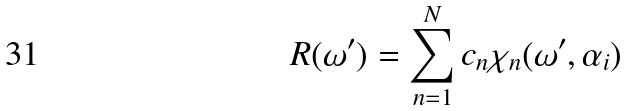<formula> <loc_0><loc_0><loc_500><loc_500>R ( \omega ^ { \prime } ) = \sum _ { n = 1 } ^ { N } c _ { n } \chi _ { n } ( \omega ^ { \prime } , \alpha _ { i } ) \,</formula> 